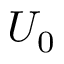<formula> <loc_0><loc_0><loc_500><loc_500>U _ { 0 }</formula> 